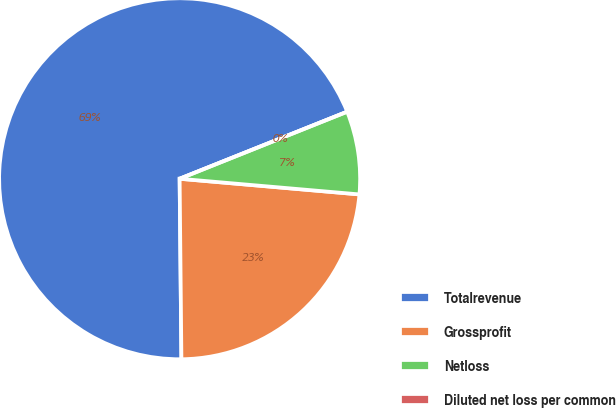Convert chart. <chart><loc_0><loc_0><loc_500><loc_500><pie_chart><fcel>Totalrevenue<fcel>Grossprofit<fcel>Netloss<fcel>Diluted net loss per common<nl><fcel>69.1%<fcel>23.46%<fcel>7.44%<fcel>0.0%<nl></chart> 